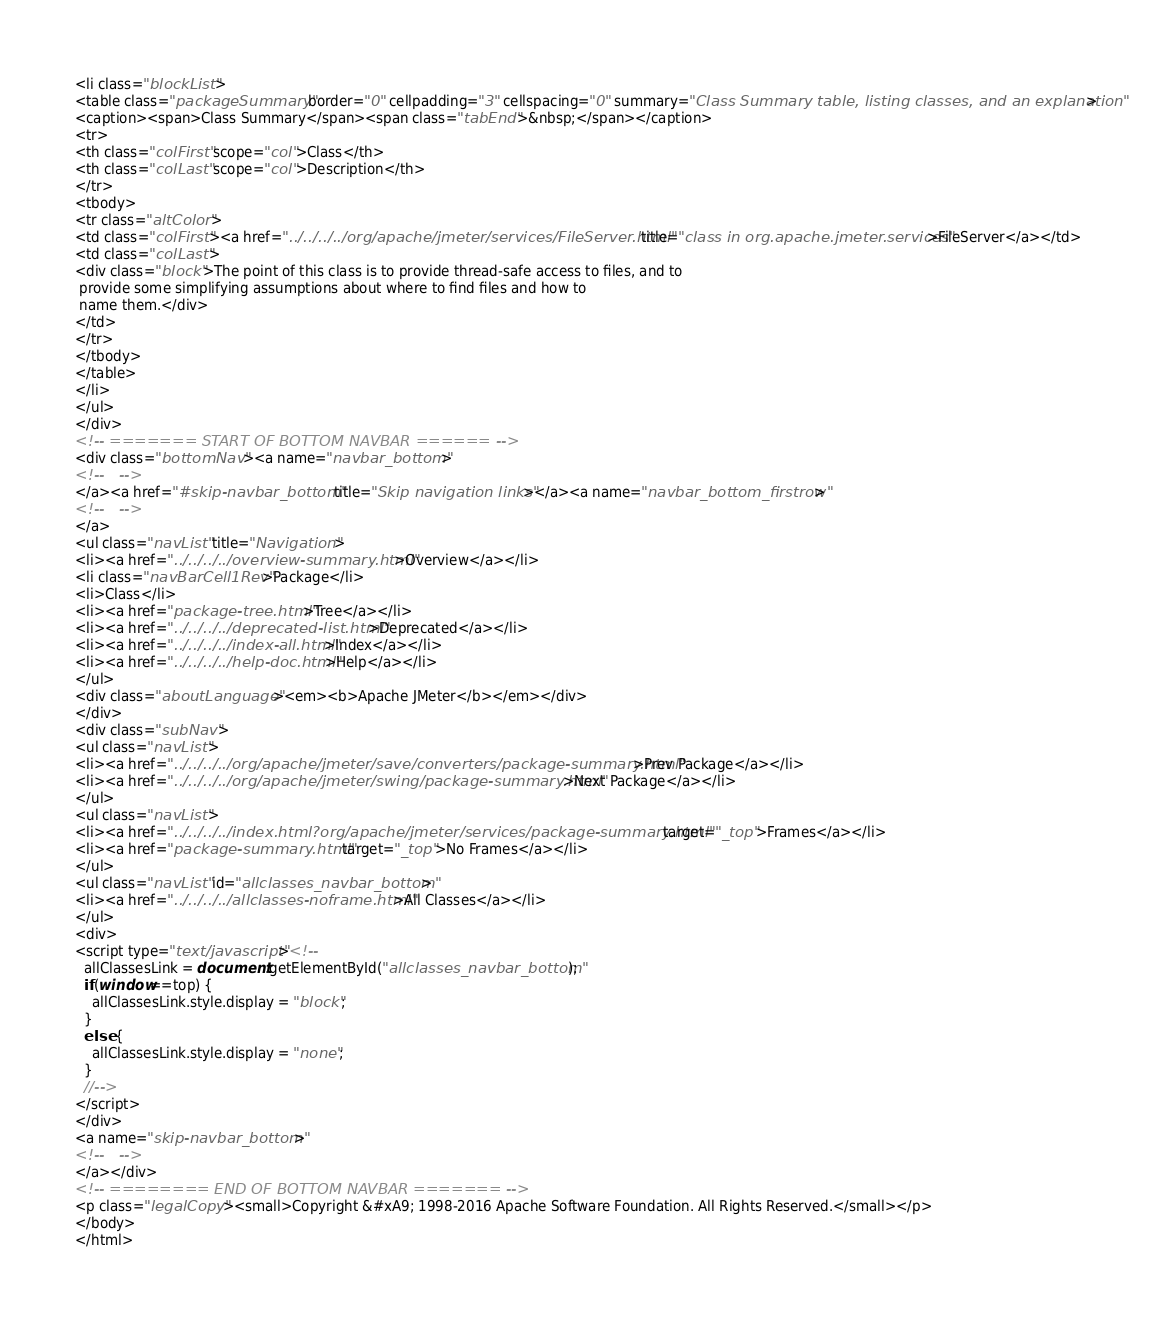<code> <loc_0><loc_0><loc_500><loc_500><_HTML_><li class="blockList">
<table class="packageSummary" border="0" cellpadding="3" cellspacing="0" summary="Class Summary table, listing classes, and an explanation">
<caption><span>Class Summary</span><span class="tabEnd">&nbsp;</span></caption>
<tr>
<th class="colFirst" scope="col">Class</th>
<th class="colLast" scope="col">Description</th>
</tr>
<tbody>
<tr class="altColor">
<td class="colFirst"><a href="../../../../org/apache/jmeter/services/FileServer.html" title="class in org.apache.jmeter.services">FileServer</a></td>
<td class="colLast">
<div class="block">The point of this class is to provide thread-safe access to files, and to
 provide some simplifying assumptions about where to find files and how to
 name them.</div>
</td>
</tr>
</tbody>
</table>
</li>
</ul>
</div>
<!-- ======= START OF BOTTOM NAVBAR ====== -->
<div class="bottomNav"><a name="navbar_bottom">
<!--   -->
</a><a href="#skip-navbar_bottom" title="Skip navigation links"></a><a name="navbar_bottom_firstrow">
<!--   -->
</a>
<ul class="navList" title="Navigation">
<li><a href="../../../../overview-summary.html">Overview</a></li>
<li class="navBarCell1Rev">Package</li>
<li>Class</li>
<li><a href="package-tree.html">Tree</a></li>
<li><a href="../../../../deprecated-list.html">Deprecated</a></li>
<li><a href="../../../../index-all.html">Index</a></li>
<li><a href="../../../../help-doc.html">Help</a></li>
</ul>
<div class="aboutLanguage"><em><b>Apache JMeter</b></em></div>
</div>
<div class="subNav">
<ul class="navList">
<li><a href="../../../../org/apache/jmeter/save/converters/package-summary.html">Prev Package</a></li>
<li><a href="../../../../org/apache/jmeter/swing/package-summary.html">Next Package</a></li>
</ul>
<ul class="navList">
<li><a href="../../../../index.html?org/apache/jmeter/services/package-summary.html" target="_top">Frames</a></li>
<li><a href="package-summary.html" target="_top">No Frames</a></li>
</ul>
<ul class="navList" id="allclasses_navbar_bottom">
<li><a href="../../../../allclasses-noframe.html">All Classes</a></li>
</ul>
<div>
<script type="text/javascript"><!--
  allClassesLink = document.getElementById("allclasses_navbar_bottom");
  if(window==top) {
    allClassesLink.style.display = "block";
  }
  else {
    allClassesLink.style.display = "none";
  }
  //-->
</script>
</div>
<a name="skip-navbar_bottom">
<!--   -->
</a></div>
<!-- ======== END OF BOTTOM NAVBAR ======= -->
<p class="legalCopy"><small>Copyright &#xA9; 1998-2016 Apache Software Foundation. All Rights Reserved.</small></p>
</body>
</html>
</code> 